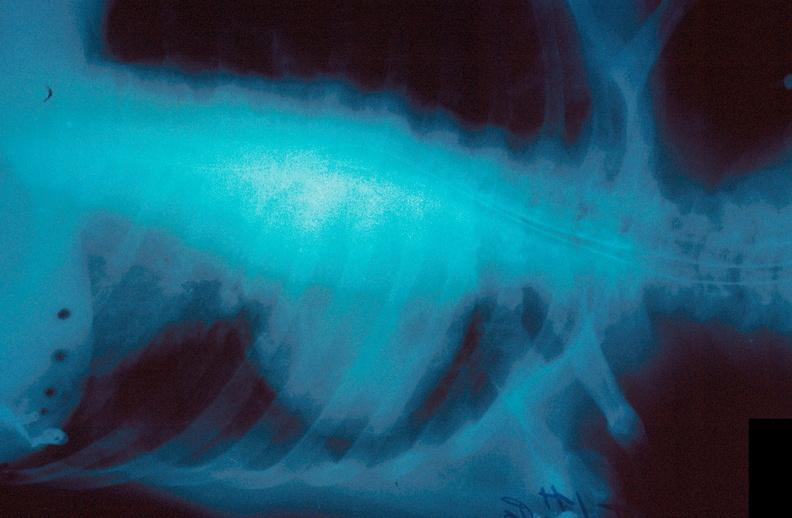s acute inflammation present?
Answer the question using a single word or phrase. No 